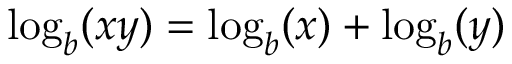Convert formula to latex. <formula><loc_0><loc_0><loc_500><loc_500>\log _ { b } ( x y ) = \log _ { b } ( x ) + \log _ { b } ( y )</formula> 